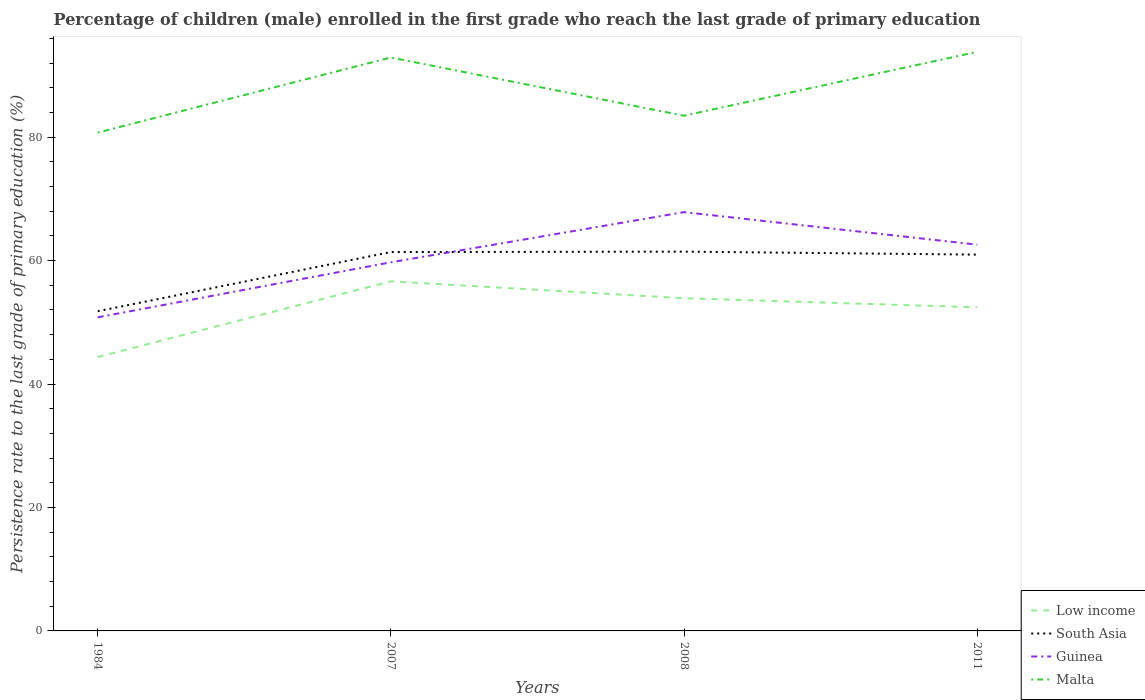How many different coloured lines are there?
Offer a terse response. 4. Across all years, what is the maximum persistence rate of children in Malta?
Provide a short and direct response. 80.74. In which year was the persistence rate of children in South Asia maximum?
Provide a short and direct response. 1984. What is the total persistence rate of children in South Asia in the graph?
Your answer should be very brief. -9.66. What is the difference between the highest and the second highest persistence rate of children in Low income?
Make the answer very short. 12.27. Is the persistence rate of children in Malta strictly greater than the persistence rate of children in Guinea over the years?
Offer a terse response. No. How many lines are there?
Your response must be concise. 4. How many years are there in the graph?
Provide a short and direct response. 4. What is the difference between two consecutive major ticks on the Y-axis?
Make the answer very short. 20. Does the graph contain any zero values?
Ensure brevity in your answer.  No. Where does the legend appear in the graph?
Your answer should be compact. Bottom right. How are the legend labels stacked?
Your answer should be compact. Vertical. What is the title of the graph?
Make the answer very short. Percentage of children (male) enrolled in the first grade who reach the last grade of primary education. Does "Jamaica" appear as one of the legend labels in the graph?
Keep it short and to the point. No. What is the label or title of the Y-axis?
Make the answer very short. Persistence rate to the last grade of primary education (%). What is the Persistence rate to the last grade of primary education (%) of Low income in 1984?
Offer a very short reply. 44.37. What is the Persistence rate to the last grade of primary education (%) in South Asia in 1984?
Offer a terse response. 51.79. What is the Persistence rate to the last grade of primary education (%) in Guinea in 1984?
Offer a terse response. 50.81. What is the Persistence rate to the last grade of primary education (%) in Malta in 1984?
Provide a succinct answer. 80.74. What is the Persistence rate to the last grade of primary education (%) of Low income in 2007?
Ensure brevity in your answer.  56.64. What is the Persistence rate to the last grade of primary education (%) in South Asia in 2007?
Your answer should be compact. 61.38. What is the Persistence rate to the last grade of primary education (%) in Guinea in 2007?
Your answer should be very brief. 59.72. What is the Persistence rate to the last grade of primary education (%) of Malta in 2007?
Keep it short and to the point. 92.9. What is the Persistence rate to the last grade of primary education (%) in Low income in 2008?
Offer a terse response. 53.9. What is the Persistence rate to the last grade of primary education (%) of South Asia in 2008?
Make the answer very short. 61.45. What is the Persistence rate to the last grade of primary education (%) of Guinea in 2008?
Make the answer very short. 67.85. What is the Persistence rate to the last grade of primary education (%) in Malta in 2008?
Your answer should be compact. 83.47. What is the Persistence rate to the last grade of primary education (%) in Low income in 2011?
Your answer should be very brief. 52.43. What is the Persistence rate to the last grade of primary education (%) in South Asia in 2011?
Your answer should be very brief. 60.96. What is the Persistence rate to the last grade of primary education (%) of Guinea in 2011?
Give a very brief answer. 62.58. What is the Persistence rate to the last grade of primary education (%) of Malta in 2011?
Offer a terse response. 93.82. Across all years, what is the maximum Persistence rate to the last grade of primary education (%) in Low income?
Offer a terse response. 56.64. Across all years, what is the maximum Persistence rate to the last grade of primary education (%) in South Asia?
Offer a very short reply. 61.45. Across all years, what is the maximum Persistence rate to the last grade of primary education (%) in Guinea?
Your response must be concise. 67.85. Across all years, what is the maximum Persistence rate to the last grade of primary education (%) in Malta?
Offer a very short reply. 93.82. Across all years, what is the minimum Persistence rate to the last grade of primary education (%) of Low income?
Your answer should be compact. 44.37. Across all years, what is the minimum Persistence rate to the last grade of primary education (%) of South Asia?
Your response must be concise. 51.79. Across all years, what is the minimum Persistence rate to the last grade of primary education (%) in Guinea?
Your response must be concise. 50.81. Across all years, what is the minimum Persistence rate to the last grade of primary education (%) of Malta?
Ensure brevity in your answer.  80.74. What is the total Persistence rate to the last grade of primary education (%) in Low income in the graph?
Offer a very short reply. 207.34. What is the total Persistence rate to the last grade of primary education (%) of South Asia in the graph?
Your response must be concise. 235.59. What is the total Persistence rate to the last grade of primary education (%) in Guinea in the graph?
Offer a terse response. 240.96. What is the total Persistence rate to the last grade of primary education (%) in Malta in the graph?
Your answer should be compact. 350.94. What is the difference between the Persistence rate to the last grade of primary education (%) in Low income in 1984 and that in 2007?
Give a very brief answer. -12.27. What is the difference between the Persistence rate to the last grade of primary education (%) in South Asia in 1984 and that in 2007?
Give a very brief answer. -9.59. What is the difference between the Persistence rate to the last grade of primary education (%) of Guinea in 1984 and that in 2007?
Offer a terse response. -8.92. What is the difference between the Persistence rate to the last grade of primary education (%) of Malta in 1984 and that in 2007?
Your answer should be very brief. -12.17. What is the difference between the Persistence rate to the last grade of primary education (%) in Low income in 1984 and that in 2008?
Ensure brevity in your answer.  -9.53. What is the difference between the Persistence rate to the last grade of primary education (%) of South Asia in 1984 and that in 2008?
Your answer should be very brief. -9.66. What is the difference between the Persistence rate to the last grade of primary education (%) in Guinea in 1984 and that in 2008?
Offer a very short reply. -17.04. What is the difference between the Persistence rate to the last grade of primary education (%) in Malta in 1984 and that in 2008?
Keep it short and to the point. -2.74. What is the difference between the Persistence rate to the last grade of primary education (%) of Low income in 1984 and that in 2011?
Your response must be concise. -8.06. What is the difference between the Persistence rate to the last grade of primary education (%) of South Asia in 1984 and that in 2011?
Ensure brevity in your answer.  -9.17. What is the difference between the Persistence rate to the last grade of primary education (%) of Guinea in 1984 and that in 2011?
Keep it short and to the point. -11.77. What is the difference between the Persistence rate to the last grade of primary education (%) in Malta in 1984 and that in 2011?
Ensure brevity in your answer.  -13.09. What is the difference between the Persistence rate to the last grade of primary education (%) of Low income in 2007 and that in 2008?
Ensure brevity in your answer.  2.74. What is the difference between the Persistence rate to the last grade of primary education (%) of South Asia in 2007 and that in 2008?
Give a very brief answer. -0.07. What is the difference between the Persistence rate to the last grade of primary education (%) in Guinea in 2007 and that in 2008?
Give a very brief answer. -8.13. What is the difference between the Persistence rate to the last grade of primary education (%) in Malta in 2007 and that in 2008?
Ensure brevity in your answer.  9.43. What is the difference between the Persistence rate to the last grade of primary education (%) in Low income in 2007 and that in 2011?
Offer a terse response. 4.21. What is the difference between the Persistence rate to the last grade of primary education (%) of South Asia in 2007 and that in 2011?
Offer a very short reply. 0.42. What is the difference between the Persistence rate to the last grade of primary education (%) in Guinea in 2007 and that in 2011?
Make the answer very short. -2.85. What is the difference between the Persistence rate to the last grade of primary education (%) in Malta in 2007 and that in 2011?
Make the answer very short. -0.92. What is the difference between the Persistence rate to the last grade of primary education (%) of Low income in 2008 and that in 2011?
Provide a succinct answer. 1.47. What is the difference between the Persistence rate to the last grade of primary education (%) of South Asia in 2008 and that in 2011?
Give a very brief answer. 0.49. What is the difference between the Persistence rate to the last grade of primary education (%) of Guinea in 2008 and that in 2011?
Ensure brevity in your answer.  5.27. What is the difference between the Persistence rate to the last grade of primary education (%) of Malta in 2008 and that in 2011?
Offer a very short reply. -10.35. What is the difference between the Persistence rate to the last grade of primary education (%) in Low income in 1984 and the Persistence rate to the last grade of primary education (%) in South Asia in 2007?
Provide a short and direct response. -17.01. What is the difference between the Persistence rate to the last grade of primary education (%) of Low income in 1984 and the Persistence rate to the last grade of primary education (%) of Guinea in 2007?
Your answer should be compact. -15.35. What is the difference between the Persistence rate to the last grade of primary education (%) in Low income in 1984 and the Persistence rate to the last grade of primary education (%) in Malta in 2007?
Provide a short and direct response. -48.53. What is the difference between the Persistence rate to the last grade of primary education (%) in South Asia in 1984 and the Persistence rate to the last grade of primary education (%) in Guinea in 2007?
Keep it short and to the point. -7.93. What is the difference between the Persistence rate to the last grade of primary education (%) in South Asia in 1984 and the Persistence rate to the last grade of primary education (%) in Malta in 2007?
Keep it short and to the point. -41.11. What is the difference between the Persistence rate to the last grade of primary education (%) in Guinea in 1984 and the Persistence rate to the last grade of primary education (%) in Malta in 2007?
Ensure brevity in your answer.  -42.09. What is the difference between the Persistence rate to the last grade of primary education (%) of Low income in 1984 and the Persistence rate to the last grade of primary education (%) of South Asia in 2008?
Keep it short and to the point. -17.08. What is the difference between the Persistence rate to the last grade of primary education (%) of Low income in 1984 and the Persistence rate to the last grade of primary education (%) of Guinea in 2008?
Your response must be concise. -23.48. What is the difference between the Persistence rate to the last grade of primary education (%) of Low income in 1984 and the Persistence rate to the last grade of primary education (%) of Malta in 2008?
Provide a short and direct response. -39.1. What is the difference between the Persistence rate to the last grade of primary education (%) of South Asia in 1984 and the Persistence rate to the last grade of primary education (%) of Guinea in 2008?
Your answer should be compact. -16.06. What is the difference between the Persistence rate to the last grade of primary education (%) in South Asia in 1984 and the Persistence rate to the last grade of primary education (%) in Malta in 2008?
Your answer should be very brief. -31.68. What is the difference between the Persistence rate to the last grade of primary education (%) of Guinea in 1984 and the Persistence rate to the last grade of primary education (%) of Malta in 2008?
Give a very brief answer. -32.66. What is the difference between the Persistence rate to the last grade of primary education (%) of Low income in 1984 and the Persistence rate to the last grade of primary education (%) of South Asia in 2011?
Keep it short and to the point. -16.59. What is the difference between the Persistence rate to the last grade of primary education (%) in Low income in 1984 and the Persistence rate to the last grade of primary education (%) in Guinea in 2011?
Provide a succinct answer. -18.21. What is the difference between the Persistence rate to the last grade of primary education (%) of Low income in 1984 and the Persistence rate to the last grade of primary education (%) of Malta in 2011?
Give a very brief answer. -49.45. What is the difference between the Persistence rate to the last grade of primary education (%) in South Asia in 1984 and the Persistence rate to the last grade of primary education (%) in Guinea in 2011?
Your answer should be very brief. -10.79. What is the difference between the Persistence rate to the last grade of primary education (%) of South Asia in 1984 and the Persistence rate to the last grade of primary education (%) of Malta in 2011?
Provide a succinct answer. -42.03. What is the difference between the Persistence rate to the last grade of primary education (%) of Guinea in 1984 and the Persistence rate to the last grade of primary education (%) of Malta in 2011?
Provide a short and direct response. -43.01. What is the difference between the Persistence rate to the last grade of primary education (%) of Low income in 2007 and the Persistence rate to the last grade of primary education (%) of South Asia in 2008?
Your answer should be very brief. -4.81. What is the difference between the Persistence rate to the last grade of primary education (%) in Low income in 2007 and the Persistence rate to the last grade of primary education (%) in Guinea in 2008?
Ensure brevity in your answer.  -11.21. What is the difference between the Persistence rate to the last grade of primary education (%) in Low income in 2007 and the Persistence rate to the last grade of primary education (%) in Malta in 2008?
Give a very brief answer. -26.83. What is the difference between the Persistence rate to the last grade of primary education (%) of South Asia in 2007 and the Persistence rate to the last grade of primary education (%) of Guinea in 2008?
Provide a short and direct response. -6.47. What is the difference between the Persistence rate to the last grade of primary education (%) of South Asia in 2007 and the Persistence rate to the last grade of primary education (%) of Malta in 2008?
Your answer should be very brief. -22.09. What is the difference between the Persistence rate to the last grade of primary education (%) of Guinea in 2007 and the Persistence rate to the last grade of primary education (%) of Malta in 2008?
Offer a very short reply. -23.75. What is the difference between the Persistence rate to the last grade of primary education (%) in Low income in 2007 and the Persistence rate to the last grade of primary education (%) in South Asia in 2011?
Provide a short and direct response. -4.33. What is the difference between the Persistence rate to the last grade of primary education (%) in Low income in 2007 and the Persistence rate to the last grade of primary education (%) in Guinea in 2011?
Give a very brief answer. -5.94. What is the difference between the Persistence rate to the last grade of primary education (%) of Low income in 2007 and the Persistence rate to the last grade of primary education (%) of Malta in 2011?
Your response must be concise. -37.18. What is the difference between the Persistence rate to the last grade of primary education (%) of South Asia in 2007 and the Persistence rate to the last grade of primary education (%) of Guinea in 2011?
Make the answer very short. -1.19. What is the difference between the Persistence rate to the last grade of primary education (%) of South Asia in 2007 and the Persistence rate to the last grade of primary education (%) of Malta in 2011?
Your answer should be compact. -32.44. What is the difference between the Persistence rate to the last grade of primary education (%) of Guinea in 2007 and the Persistence rate to the last grade of primary education (%) of Malta in 2011?
Keep it short and to the point. -34.1. What is the difference between the Persistence rate to the last grade of primary education (%) of Low income in 2008 and the Persistence rate to the last grade of primary education (%) of South Asia in 2011?
Offer a terse response. -7.06. What is the difference between the Persistence rate to the last grade of primary education (%) in Low income in 2008 and the Persistence rate to the last grade of primary education (%) in Guinea in 2011?
Provide a short and direct response. -8.68. What is the difference between the Persistence rate to the last grade of primary education (%) of Low income in 2008 and the Persistence rate to the last grade of primary education (%) of Malta in 2011?
Offer a terse response. -39.92. What is the difference between the Persistence rate to the last grade of primary education (%) in South Asia in 2008 and the Persistence rate to the last grade of primary education (%) in Guinea in 2011?
Your answer should be compact. -1.13. What is the difference between the Persistence rate to the last grade of primary education (%) of South Asia in 2008 and the Persistence rate to the last grade of primary education (%) of Malta in 2011?
Offer a terse response. -32.37. What is the difference between the Persistence rate to the last grade of primary education (%) in Guinea in 2008 and the Persistence rate to the last grade of primary education (%) in Malta in 2011?
Your response must be concise. -25.97. What is the average Persistence rate to the last grade of primary education (%) of Low income per year?
Offer a very short reply. 51.84. What is the average Persistence rate to the last grade of primary education (%) of South Asia per year?
Ensure brevity in your answer.  58.9. What is the average Persistence rate to the last grade of primary education (%) of Guinea per year?
Offer a terse response. 60.24. What is the average Persistence rate to the last grade of primary education (%) in Malta per year?
Provide a short and direct response. 87.73. In the year 1984, what is the difference between the Persistence rate to the last grade of primary education (%) of Low income and Persistence rate to the last grade of primary education (%) of South Asia?
Your answer should be very brief. -7.42. In the year 1984, what is the difference between the Persistence rate to the last grade of primary education (%) in Low income and Persistence rate to the last grade of primary education (%) in Guinea?
Keep it short and to the point. -6.44. In the year 1984, what is the difference between the Persistence rate to the last grade of primary education (%) of Low income and Persistence rate to the last grade of primary education (%) of Malta?
Your response must be concise. -36.36. In the year 1984, what is the difference between the Persistence rate to the last grade of primary education (%) in South Asia and Persistence rate to the last grade of primary education (%) in Guinea?
Ensure brevity in your answer.  0.98. In the year 1984, what is the difference between the Persistence rate to the last grade of primary education (%) in South Asia and Persistence rate to the last grade of primary education (%) in Malta?
Offer a very short reply. -28.94. In the year 1984, what is the difference between the Persistence rate to the last grade of primary education (%) of Guinea and Persistence rate to the last grade of primary education (%) of Malta?
Your response must be concise. -29.93. In the year 2007, what is the difference between the Persistence rate to the last grade of primary education (%) of Low income and Persistence rate to the last grade of primary education (%) of South Asia?
Offer a terse response. -4.75. In the year 2007, what is the difference between the Persistence rate to the last grade of primary education (%) in Low income and Persistence rate to the last grade of primary education (%) in Guinea?
Offer a very short reply. -3.09. In the year 2007, what is the difference between the Persistence rate to the last grade of primary education (%) of Low income and Persistence rate to the last grade of primary education (%) of Malta?
Make the answer very short. -36.27. In the year 2007, what is the difference between the Persistence rate to the last grade of primary education (%) of South Asia and Persistence rate to the last grade of primary education (%) of Guinea?
Ensure brevity in your answer.  1.66. In the year 2007, what is the difference between the Persistence rate to the last grade of primary education (%) in South Asia and Persistence rate to the last grade of primary education (%) in Malta?
Ensure brevity in your answer.  -31.52. In the year 2007, what is the difference between the Persistence rate to the last grade of primary education (%) in Guinea and Persistence rate to the last grade of primary education (%) in Malta?
Your answer should be very brief. -33.18. In the year 2008, what is the difference between the Persistence rate to the last grade of primary education (%) of Low income and Persistence rate to the last grade of primary education (%) of South Asia?
Your response must be concise. -7.55. In the year 2008, what is the difference between the Persistence rate to the last grade of primary education (%) of Low income and Persistence rate to the last grade of primary education (%) of Guinea?
Provide a succinct answer. -13.95. In the year 2008, what is the difference between the Persistence rate to the last grade of primary education (%) in Low income and Persistence rate to the last grade of primary education (%) in Malta?
Offer a very short reply. -29.57. In the year 2008, what is the difference between the Persistence rate to the last grade of primary education (%) in South Asia and Persistence rate to the last grade of primary education (%) in Guinea?
Your response must be concise. -6.4. In the year 2008, what is the difference between the Persistence rate to the last grade of primary education (%) of South Asia and Persistence rate to the last grade of primary education (%) of Malta?
Your answer should be compact. -22.02. In the year 2008, what is the difference between the Persistence rate to the last grade of primary education (%) in Guinea and Persistence rate to the last grade of primary education (%) in Malta?
Offer a terse response. -15.62. In the year 2011, what is the difference between the Persistence rate to the last grade of primary education (%) of Low income and Persistence rate to the last grade of primary education (%) of South Asia?
Your response must be concise. -8.53. In the year 2011, what is the difference between the Persistence rate to the last grade of primary education (%) in Low income and Persistence rate to the last grade of primary education (%) in Guinea?
Your answer should be compact. -10.15. In the year 2011, what is the difference between the Persistence rate to the last grade of primary education (%) in Low income and Persistence rate to the last grade of primary education (%) in Malta?
Ensure brevity in your answer.  -41.39. In the year 2011, what is the difference between the Persistence rate to the last grade of primary education (%) of South Asia and Persistence rate to the last grade of primary education (%) of Guinea?
Offer a very short reply. -1.61. In the year 2011, what is the difference between the Persistence rate to the last grade of primary education (%) in South Asia and Persistence rate to the last grade of primary education (%) in Malta?
Make the answer very short. -32.86. In the year 2011, what is the difference between the Persistence rate to the last grade of primary education (%) in Guinea and Persistence rate to the last grade of primary education (%) in Malta?
Make the answer very short. -31.24. What is the ratio of the Persistence rate to the last grade of primary education (%) of Low income in 1984 to that in 2007?
Make the answer very short. 0.78. What is the ratio of the Persistence rate to the last grade of primary education (%) in South Asia in 1984 to that in 2007?
Offer a terse response. 0.84. What is the ratio of the Persistence rate to the last grade of primary education (%) in Guinea in 1984 to that in 2007?
Make the answer very short. 0.85. What is the ratio of the Persistence rate to the last grade of primary education (%) of Malta in 1984 to that in 2007?
Offer a terse response. 0.87. What is the ratio of the Persistence rate to the last grade of primary education (%) in Low income in 1984 to that in 2008?
Ensure brevity in your answer.  0.82. What is the ratio of the Persistence rate to the last grade of primary education (%) in South Asia in 1984 to that in 2008?
Keep it short and to the point. 0.84. What is the ratio of the Persistence rate to the last grade of primary education (%) in Guinea in 1984 to that in 2008?
Your answer should be very brief. 0.75. What is the ratio of the Persistence rate to the last grade of primary education (%) in Malta in 1984 to that in 2008?
Offer a terse response. 0.97. What is the ratio of the Persistence rate to the last grade of primary education (%) in Low income in 1984 to that in 2011?
Provide a succinct answer. 0.85. What is the ratio of the Persistence rate to the last grade of primary education (%) of South Asia in 1984 to that in 2011?
Offer a very short reply. 0.85. What is the ratio of the Persistence rate to the last grade of primary education (%) of Guinea in 1984 to that in 2011?
Your response must be concise. 0.81. What is the ratio of the Persistence rate to the last grade of primary education (%) in Malta in 1984 to that in 2011?
Make the answer very short. 0.86. What is the ratio of the Persistence rate to the last grade of primary education (%) in Low income in 2007 to that in 2008?
Your answer should be very brief. 1.05. What is the ratio of the Persistence rate to the last grade of primary education (%) in South Asia in 2007 to that in 2008?
Offer a terse response. 1. What is the ratio of the Persistence rate to the last grade of primary education (%) in Guinea in 2007 to that in 2008?
Your answer should be very brief. 0.88. What is the ratio of the Persistence rate to the last grade of primary education (%) of Malta in 2007 to that in 2008?
Your answer should be compact. 1.11. What is the ratio of the Persistence rate to the last grade of primary education (%) in Low income in 2007 to that in 2011?
Provide a succinct answer. 1.08. What is the ratio of the Persistence rate to the last grade of primary education (%) in South Asia in 2007 to that in 2011?
Offer a terse response. 1.01. What is the ratio of the Persistence rate to the last grade of primary education (%) of Guinea in 2007 to that in 2011?
Provide a succinct answer. 0.95. What is the ratio of the Persistence rate to the last grade of primary education (%) of Malta in 2007 to that in 2011?
Make the answer very short. 0.99. What is the ratio of the Persistence rate to the last grade of primary education (%) in Low income in 2008 to that in 2011?
Give a very brief answer. 1.03. What is the ratio of the Persistence rate to the last grade of primary education (%) of Guinea in 2008 to that in 2011?
Offer a very short reply. 1.08. What is the ratio of the Persistence rate to the last grade of primary education (%) of Malta in 2008 to that in 2011?
Give a very brief answer. 0.89. What is the difference between the highest and the second highest Persistence rate to the last grade of primary education (%) in Low income?
Offer a very short reply. 2.74. What is the difference between the highest and the second highest Persistence rate to the last grade of primary education (%) in South Asia?
Give a very brief answer. 0.07. What is the difference between the highest and the second highest Persistence rate to the last grade of primary education (%) of Guinea?
Your response must be concise. 5.27. What is the difference between the highest and the second highest Persistence rate to the last grade of primary education (%) of Malta?
Give a very brief answer. 0.92. What is the difference between the highest and the lowest Persistence rate to the last grade of primary education (%) of Low income?
Your answer should be compact. 12.27. What is the difference between the highest and the lowest Persistence rate to the last grade of primary education (%) of South Asia?
Make the answer very short. 9.66. What is the difference between the highest and the lowest Persistence rate to the last grade of primary education (%) of Guinea?
Give a very brief answer. 17.04. What is the difference between the highest and the lowest Persistence rate to the last grade of primary education (%) in Malta?
Make the answer very short. 13.09. 